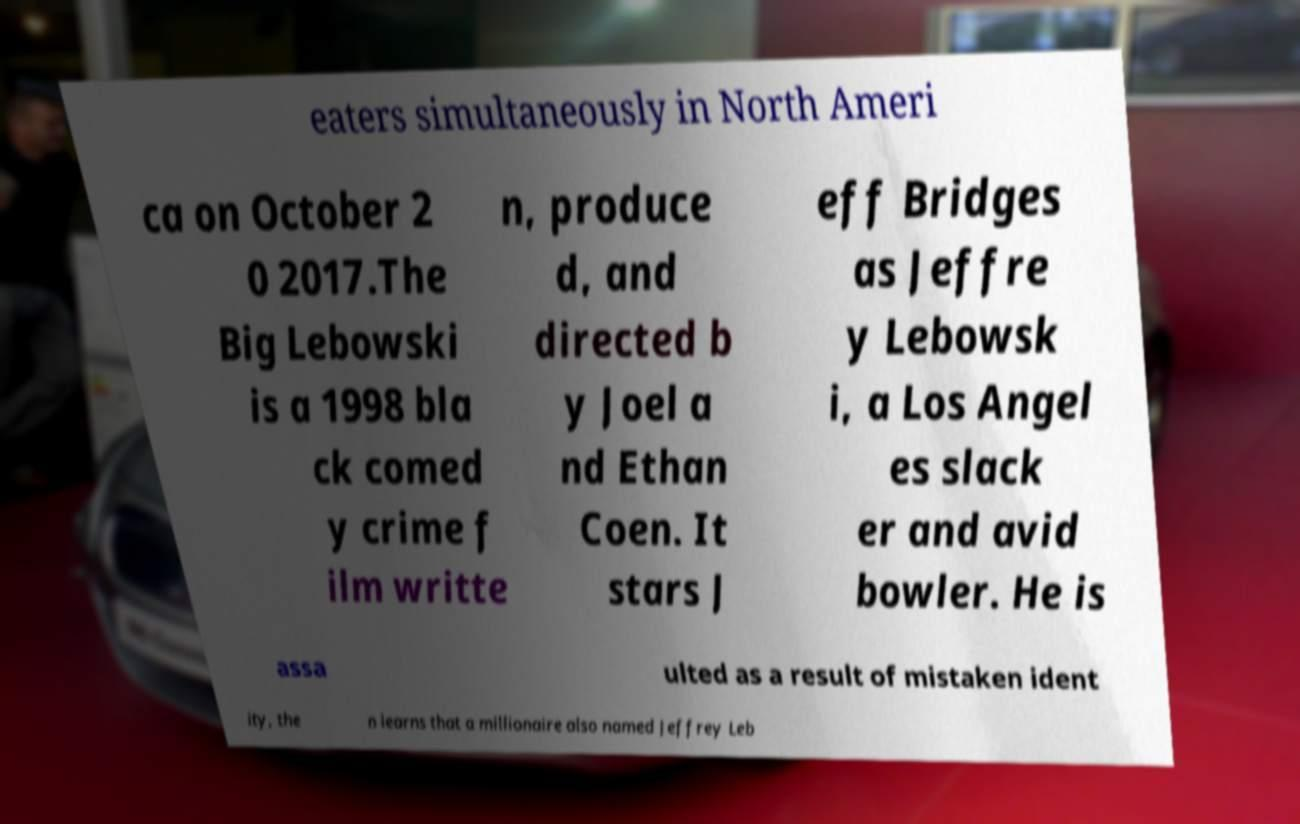Could you extract and type out the text from this image? eaters simultaneously in North Ameri ca on October 2 0 2017.The Big Lebowski is a 1998 bla ck comed y crime f ilm writte n, produce d, and directed b y Joel a nd Ethan Coen. It stars J eff Bridges as Jeffre y Lebowsk i, a Los Angel es slack er and avid bowler. He is assa ulted as a result of mistaken ident ity, the n learns that a millionaire also named Jeffrey Leb 